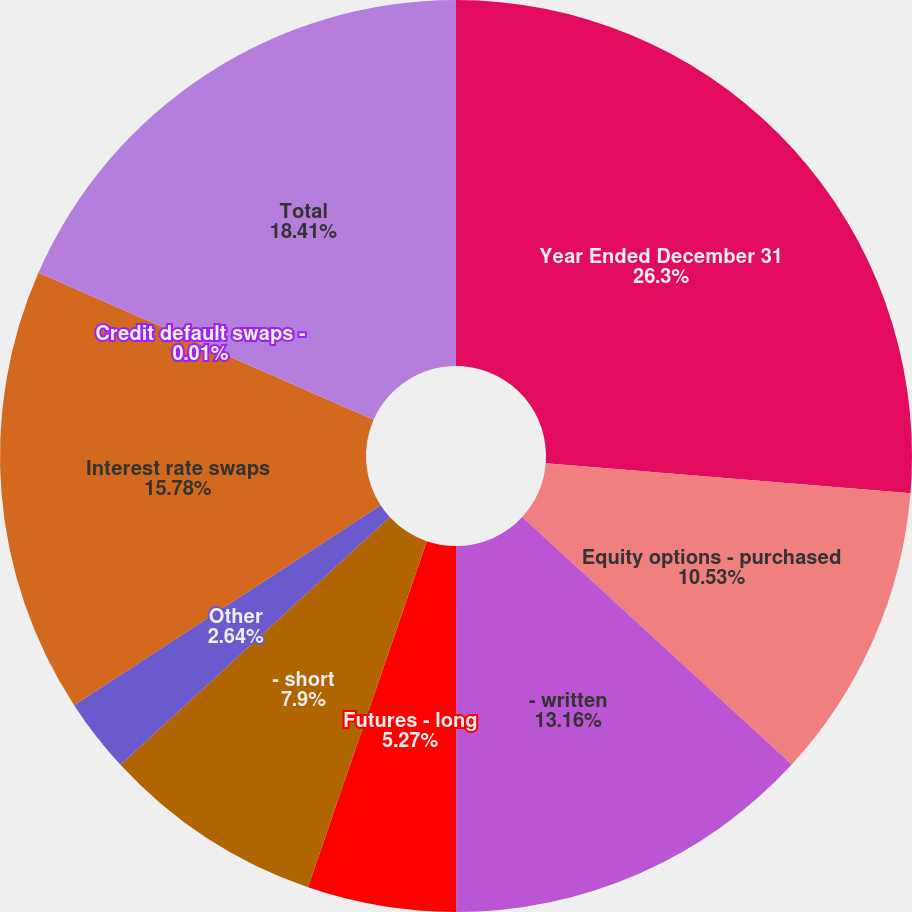Convert chart. <chart><loc_0><loc_0><loc_500><loc_500><pie_chart><fcel>Year Ended December 31<fcel>Equity options - purchased<fcel>- written<fcel>Futures - long<fcel>- short<fcel>Other<fcel>Interest rate swaps<fcel>Credit default swaps -<fcel>Total<nl><fcel>26.3%<fcel>10.53%<fcel>13.16%<fcel>5.27%<fcel>7.9%<fcel>2.64%<fcel>15.78%<fcel>0.01%<fcel>18.41%<nl></chart> 